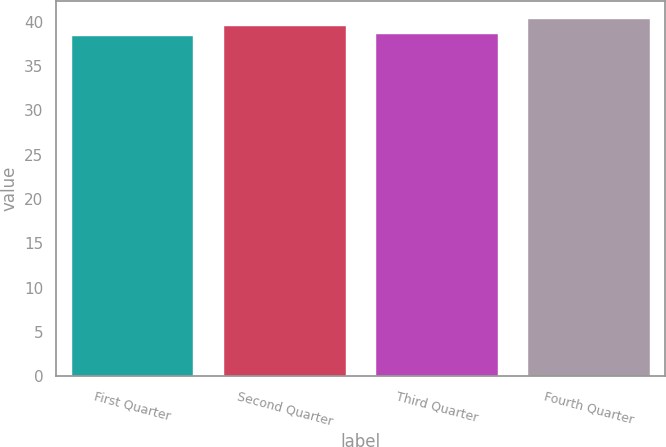<chart> <loc_0><loc_0><loc_500><loc_500><bar_chart><fcel>First Quarter<fcel>Second Quarter<fcel>Third Quarter<fcel>Fourth Quarter<nl><fcel>38.41<fcel>39.47<fcel>38.6<fcel>40.34<nl></chart> 